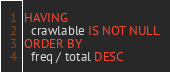<code> <loc_0><loc_0><loc_500><loc_500><_SQL_>HAVING
  crawlable IS NOT NULL
ORDER BY
  freq / total DESC
</code> 